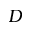<formula> <loc_0><loc_0><loc_500><loc_500>D</formula> 